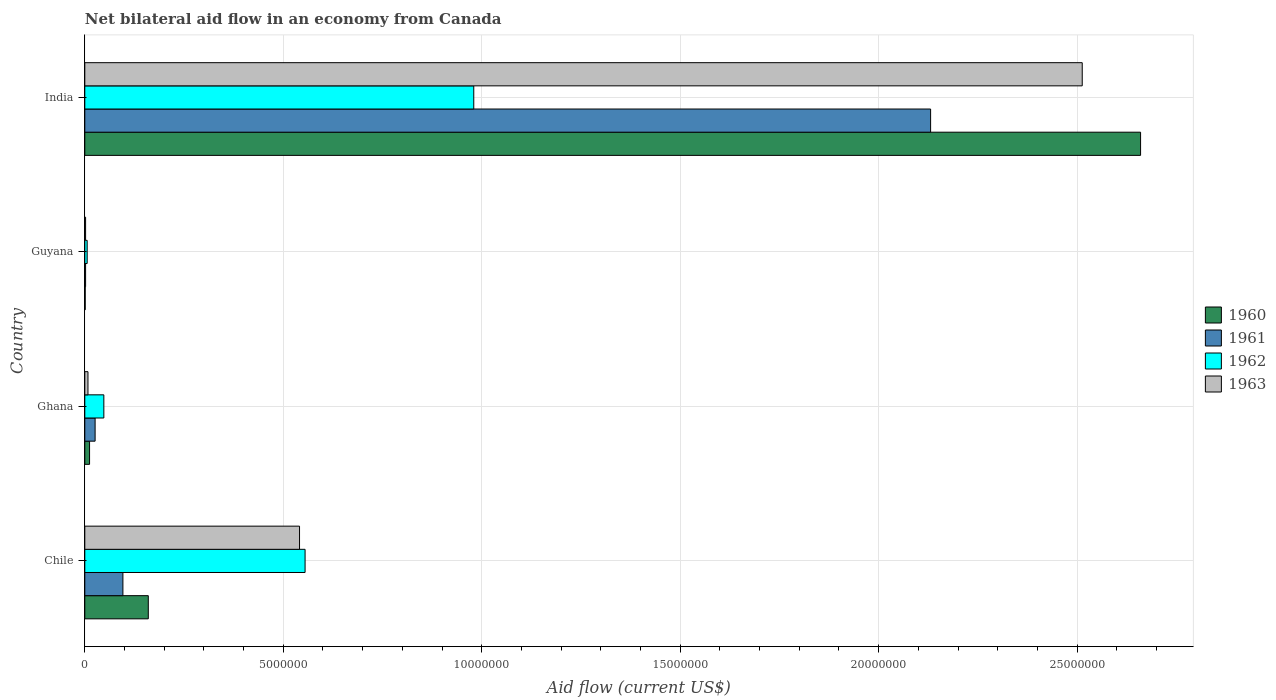How many groups of bars are there?
Provide a succinct answer. 4. Are the number of bars per tick equal to the number of legend labels?
Keep it short and to the point. Yes. Are the number of bars on each tick of the Y-axis equal?
Your answer should be compact. Yes. What is the net bilateral aid flow in 1962 in Ghana?
Your answer should be very brief. 4.80e+05. Across all countries, what is the maximum net bilateral aid flow in 1960?
Your response must be concise. 2.66e+07. In which country was the net bilateral aid flow in 1962 minimum?
Offer a terse response. Guyana. What is the total net bilateral aid flow in 1963 in the graph?
Provide a succinct answer. 3.06e+07. What is the difference between the net bilateral aid flow in 1963 in Guyana and that in India?
Provide a short and direct response. -2.51e+07. What is the difference between the net bilateral aid flow in 1962 in India and the net bilateral aid flow in 1960 in Ghana?
Offer a very short reply. 9.68e+06. What is the average net bilateral aid flow in 1963 per country?
Your answer should be compact. 7.66e+06. In how many countries, is the net bilateral aid flow in 1960 greater than 1000000 US$?
Keep it short and to the point. 2. What is the ratio of the net bilateral aid flow in 1961 in Chile to that in Ghana?
Ensure brevity in your answer.  3.69. Is the net bilateral aid flow in 1960 in Chile less than that in India?
Provide a short and direct response. Yes. What is the difference between the highest and the second highest net bilateral aid flow in 1963?
Your response must be concise. 1.97e+07. What is the difference between the highest and the lowest net bilateral aid flow in 1963?
Provide a succinct answer. 2.51e+07. Is the sum of the net bilateral aid flow in 1960 in Chile and India greater than the maximum net bilateral aid flow in 1961 across all countries?
Give a very brief answer. Yes. Is it the case that in every country, the sum of the net bilateral aid flow in 1963 and net bilateral aid flow in 1961 is greater than the sum of net bilateral aid flow in 1962 and net bilateral aid flow in 1960?
Provide a succinct answer. No. Are all the bars in the graph horizontal?
Ensure brevity in your answer.  Yes. How many countries are there in the graph?
Give a very brief answer. 4. Are the values on the major ticks of X-axis written in scientific E-notation?
Give a very brief answer. No. Does the graph contain grids?
Your answer should be very brief. Yes. How many legend labels are there?
Make the answer very short. 4. What is the title of the graph?
Keep it short and to the point. Net bilateral aid flow in an economy from Canada. What is the label or title of the Y-axis?
Provide a short and direct response. Country. What is the Aid flow (current US$) of 1960 in Chile?
Ensure brevity in your answer.  1.60e+06. What is the Aid flow (current US$) in 1961 in Chile?
Ensure brevity in your answer.  9.60e+05. What is the Aid flow (current US$) in 1962 in Chile?
Give a very brief answer. 5.55e+06. What is the Aid flow (current US$) of 1963 in Chile?
Your answer should be very brief. 5.41e+06. What is the Aid flow (current US$) of 1960 in Ghana?
Ensure brevity in your answer.  1.20e+05. What is the Aid flow (current US$) in 1961 in Ghana?
Keep it short and to the point. 2.60e+05. What is the Aid flow (current US$) of 1962 in Ghana?
Provide a succinct answer. 4.80e+05. What is the Aid flow (current US$) of 1963 in Ghana?
Your answer should be compact. 8.00e+04. What is the Aid flow (current US$) of 1960 in Guyana?
Offer a very short reply. 10000. What is the Aid flow (current US$) of 1962 in Guyana?
Offer a very short reply. 6.00e+04. What is the Aid flow (current US$) in 1960 in India?
Your answer should be compact. 2.66e+07. What is the Aid flow (current US$) of 1961 in India?
Make the answer very short. 2.13e+07. What is the Aid flow (current US$) in 1962 in India?
Offer a terse response. 9.80e+06. What is the Aid flow (current US$) of 1963 in India?
Your answer should be compact. 2.51e+07. Across all countries, what is the maximum Aid flow (current US$) of 1960?
Keep it short and to the point. 2.66e+07. Across all countries, what is the maximum Aid flow (current US$) in 1961?
Provide a succinct answer. 2.13e+07. Across all countries, what is the maximum Aid flow (current US$) in 1962?
Make the answer very short. 9.80e+06. Across all countries, what is the maximum Aid flow (current US$) in 1963?
Provide a short and direct response. 2.51e+07. Across all countries, what is the minimum Aid flow (current US$) in 1960?
Provide a short and direct response. 10000. Across all countries, what is the minimum Aid flow (current US$) in 1961?
Provide a short and direct response. 2.00e+04. What is the total Aid flow (current US$) of 1960 in the graph?
Ensure brevity in your answer.  2.83e+07. What is the total Aid flow (current US$) in 1961 in the graph?
Give a very brief answer. 2.26e+07. What is the total Aid flow (current US$) in 1962 in the graph?
Give a very brief answer. 1.59e+07. What is the total Aid flow (current US$) of 1963 in the graph?
Provide a succinct answer. 3.06e+07. What is the difference between the Aid flow (current US$) of 1960 in Chile and that in Ghana?
Your answer should be very brief. 1.48e+06. What is the difference between the Aid flow (current US$) of 1961 in Chile and that in Ghana?
Provide a succinct answer. 7.00e+05. What is the difference between the Aid flow (current US$) in 1962 in Chile and that in Ghana?
Make the answer very short. 5.07e+06. What is the difference between the Aid flow (current US$) of 1963 in Chile and that in Ghana?
Provide a succinct answer. 5.33e+06. What is the difference between the Aid flow (current US$) in 1960 in Chile and that in Guyana?
Provide a short and direct response. 1.59e+06. What is the difference between the Aid flow (current US$) in 1961 in Chile and that in Guyana?
Provide a short and direct response. 9.40e+05. What is the difference between the Aid flow (current US$) in 1962 in Chile and that in Guyana?
Your answer should be compact. 5.49e+06. What is the difference between the Aid flow (current US$) of 1963 in Chile and that in Guyana?
Provide a succinct answer. 5.39e+06. What is the difference between the Aid flow (current US$) of 1960 in Chile and that in India?
Provide a short and direct response. -2.50e+07. What is the difference between the Aid flow (current US$) in 1961 in Chile and that in India?
Provide a succinct answer. -2.04e+07. What is the difference between the Aid flow (current US$) in 1962 in Chile and that in India?
Provide a succinct answer. -4.25e+06. What is the difference between the Aid flow (current US$) of 1963 in Chile and that in India?
Your answer should be compact. -1.97e+07. What is the difference between the Aid flow (current US$) in 1961 in Ghana and that in Guyana?
Your answer should be very brief. 2.40e+05. What is the difference between the Aid flow (current US$) of 1960 in Ghana and that in India?
Offer a terse response. -2.65e+07. What is the difference between the Aid flow (current US$) of 1961 in Ghana and that in India?
Your response must be concise. -2.10e+07. What is the difference between the Aid flow (current US$) in 1962 in Ghana and that in India?
Make the answer very short. -9.32e+06. What is the difference between the Aid flow (current US$) of 1963 in Ghana and that in India?
Make the answer very short. -2.50e+07. What is the difference between the Aid flow (current US$) in 1960 in Guyana and that in India?
Make the answer very short. -2.66e+07. What is the difference between the Aid flow (current US$) of 1961 in Guyana and that in India?
Keep it short and to the point. -2.13e+07. What is the difference between the Aid flow (current US$) in 1962 in Guyana and that in India?
Give a very brief answer. -9.74e+06. What is the difference between the Aid flow (current US$) of 1963 in Guyana and that in India?
Your answer should be very brief. -2.51e+07. What is the difference between the Aid flow (current US$) of 1960 in Chile and the Aid flow (current US$) of 1961 in Ghana?
Your response must be concise. 1.34e+06. What is the difference between the Aid flow (current US$) of 1960 in Chile and the Aid flow (current US$) of 1962 in Ghana?
Make the answer very short. 1.12e+06. What is the difference between the Aid flow (current US$) of 1960 in Chile and the Aid flow (current US$) of 1963 in Ghana?
Provide a succinct answer. 1.52e+06. What is the difference between the Aid flow (current US$) of 1961 in Chile and the Aid flow (current US$) of 1963 in Ghana?
Make the answer very short. 8.80e+05. What is the difference between the Aid flow (current US$) of 1962 in Chile and the Aid flow (current US$) of 1963 in Ghana?
Keep it short and to the point. 5.47e+06. What is the difference between the Aid flow (current US$) in 1960 in Chile and the Aid flow (current US$) in 1961 in Guyana?
Make the answer very short. 1.58e+06. What is the difference between the Aid flow (current US$) of 1960 in Chile and the Aid flow (current US$) of 1962 in Guyana?
Your answer should be compact. 1.54e+06. What is the difference between the Aid flow (current US$) in 1960 in Chile and the Aid flow (current US$) in 1963 in Guyana?
Provide a succinct answer. 1.58e+06. What is the difference between the Aid flow (current US$) of 1961 in Chile and the Aid flow (current US$) of 1962 in Guyana?
Your response must be concise. 9.00e+05. What is the difference between the Aid flow (current US$) of 1961 in Chile and the Aid flow (current US$) of 1963 in Guyana?
Make the answer very short. 9.40e+05. What is the difference between the Aid flow (current US$) of 1962 in Chile and the Aid flow (current US$) of 1963 in Guyana?
Ensure brevity in your answer.  5.53e+06. What is the difference between the Aid flow (current US$) of 1960 in Chile and the Aid flow (current US$) of 1961 in India?
Give a very brief answer. -1.97e+07. What is the difference between the Aid flow (current US$) of 1960 in Chile and the Aid flow (current US$) of 1962 in India?
Give a very brief answer. -8.20e+06. What is the difference between the Aid flow (current US$) in 1960 in Chile and the Aid flow (current US$) in 1963 in India?
Ensure brevity in your answer.  -2.35e+07. What is the difference between the Aid flow (current US$) in 1961 in Chile and the Aid flow (current US$) in 1962 in India?
Provide a short and direct response. -8.84e+06. What is the difference between the Aid flow (current US$) of 1961 in Chile and the Aid flow (current US$) of 1963 in India?
Ensure brevity in your answer.  -2.42e+07. What is the difference between the Aid flow (current US$) in 1962 in Chile and the Aid flow (current US$) in 1963 in India?
Keep it short and to the point. -1.96e+07. What is the difference between the Aid flow (current US$) in 1960 in Ghana and the Aid flow (current US$) in 1961 in Guyana?
Your response must be concise. 1.00e+05. What is the difference between the Aid flow (current US$) of 1960 in Ghana and the Aid flow (current US$) of 1963 in Guyana?
Offer a very short reply. 1.00e+05. What is the difference between the Aid flow (current US$) of 1961 in Ghana and the Aid flow (current US$) of 1962 in Guyana?
Offer a terse response. 2.00e+05. What is the difference between the Aid flow (current US$) in 1961 in Ghana and the Aid flow (current US$) in 1963 in Guyana?
Your answer should be compact. 2.40e+05. What is the difference between the Aid flow (current US$) in 1962 in Ghana and the Aid flow (current US$) in 1963 in Guyana?
Keep it short and to the point. 4.60e+05. What is the difference between the Aid flow (current US$) in 1960 in Ghana and the Aid flow (current US$) in 1961 in India?
Your answer should be very brief. -2.12e+07. What is the difference between the Aid flow (current US$) of 1960 in Ghana and the Aid flow (current US$) of 1962 in India?
Give a very brief answer. -9.68e+06. What is the difference between the Aid flow (current US$) in 1960 in Ghana and the Aid flow (current US$) in 1963 in India?
Provide a short and direct response. -2.50e+07. What is the difference between the Aid flow (current US$) in 1961 in Ghana and the Aid flow (current US$) in 1962 in India?
Your answer should be compact. -9.54e+06. What is the difference between the Aid flow (current US$) in 1961 in Ghana and the Aid flow (current US$) in 1963 in India?
Offer a very short reply. -2.49e+07. What is the difference between the Aid flow (current US$) in 1962 in Ghana and the Aid flow (current US$) in 1963 in India?
Keep it short and to the point. -2.46e+07. What is the difference between the Aid flow (current US$) in 1960 in Guyana and the Aid flow (current US$) in 1961 in India?
Offer a terse response. -2.13e+07. What is the difference between the Aid flow (current US$) of 1960 in Guyana and the Aid flow (current US$) of 1962 in India?
Ensure brevity in your answer.  -9.79e+06. What is the difference between the Aid flow (current US$) in 1960 in Guyana and the Aid flow (current US$) in 1963 in India?
Offer a terse response. -2.51e+07. What is the difference between the Aid flow (current US$) in 1961 in Guyana and the Aid flow (current US$) in 1962 in India?
Keep it short and to the point. -9.78e+06. What is the difference between the Aid flow (current US$) in 1961 in Guyana and the Aid flow (current US$) in 1963 in India?
Offer a terse response. -2.51e+07. What is the difference between the Aid flow (current US$) of 1962 in Guyana and the Aid flow (current US$) of 1963 in India?
Your answer should be very brief. -2.51e+07. What is the average Aid flow (current US$) in 1960 per country?
Offer a very short reply. 7.08e+06. What is the average Aid flow (current US$) of 1961 per country?
Provide a short and direct response. 5.64e+06. What is the average Aid flow (current US$) in 1962 per country?
Give a very brief answer. 3.97e+06. What is the average Aid flow (current US$) in 1963 per country?
Provide a short and direct response. 7.66e+06. What is the difference between the Aid flow (current US$) of 1960 and Aid flow (current US$) of 1961 in Chile?
Provide a short and direct response. 6.40e+05. What is the difference between the Aid flow (current US$) of 1960 and Aid flow (current US$) of 1962 in Chile?
Keep it short and to the point. -3.95e+06. What is the difference between the Aid flow (current US$) of 1960 and Aid flow (current US$) of 1963 in Chile?
Provide a succinct answer. -3.81e+06. What is the difference between the Aid flow (current US$) in 1961 and Aid flow (current US$) in 1962 in Chile?
Your response must be concise. -4.59e+06. What is the difference between the Aid flow (current US$) of 1961 and Aid flow (current US$) of 1963 in Chile?
Make the answer very short. -4.45e+06. What is the difference between the Aid flow (current US$) in 1960 and Aid flow (current US$) in 1961 in Ghana?
Keep it short and to the point. -1.40e+05. What is the difference between the Aid flow (current US$) in 1960 and Aid flow (current US$) in 1962 in Ghana?
Your answer should be very brief. -3.60e+05. What is the difference between the Aid flow (current US$) of 1960 and Aid flow (current US$) of 1963 in Ghana?
Your response must be concise. 4.00e+04. What is the difference between the Aid flow (current US$) in 1961 and Aid flow (current US$) in 1963 in Ghana?
Ensure brevity in your answer.  1.80e+05. What is the difference between the Aid flow (current US$) in 1962 and Aid flow (current US$) in 1963 in Ghana?
Your answer should be compact. 4.00e+05. What is the difference between the Aid flow (current US$) of 1960 and Aid flow (current US$) of 1961 in Guyana?
Offer a very short reply. -10000. What is the difference between the Aid flow (current US$) in 1960 and Aid flow (current US$) in 1963 in Guyana?
Your answer should be compact. -10000. What is the difference between the Aid flow (current US$) in 1960 and Aid flow (current US$) in 1961 in India?
Offer a terse response. 5.29e+06. What is the difference between the Aid flow (current US$) in 1960 and Aid flow (current US$) in 1962 in India?
Your answer should be very brief. 1.68e+07. What is the difference between the Aid flow (current US$) in 1960 and Aid flow (current US$) in 1963 in India?
Ensure brevity in your answer.  1.47e+06. What is the difference between the Aid flow (current US$) in 1961 and Aid flow (current US$) in 1962 in India?
Your answer should be very brief. 1.15e+07. What is the difference between the Aid flow (current US$) of 1961 and Aid flow (current US$) of 1963 in India?
Your answer should be very brief. -3.82e+06. What is the difference between the Aid flow (current US$) in 1962 and Aid flow (current US$) in 1963 in India?
Provide a short and direct response. -1.53e+07. What is the ratio of the Aid flow (current US$) of 1960 in Chile to that in Ghana?
Offer a very short reply. 13.33. What is the ratio of the Aid flow (current US$) in 1961 in Chile to that in Ghana?
Provide a short and direct response. 3.69. What is the ratio of the Aid flow (current US$) of 1962 in Chile to that in Ghana?
Your response must be concise. 11.56. What is the ratio of the Aid flow (current US$) in 1963 in Chile to that in Ghana?
Offer a very short reply. 67.62. What is the ratio of the Aid flow (current US$) of 1960 in Chile to that in Guyana?
Make the answer very short. 160. What is the ratio of the Aid flow (current US$) in 1962 in Chile to that in Guyana?
Make the answer very short. 92.5. What is the ratio of the Aid flow (current US$) in 1963 in Chile to that in Guyana?
Your answer should be very brief. 270.5. What is the ratio of the Aid flow (current US$) in 1960 in Chile to that in India?
Your response must be concise. 0.06. What is the ratio of the Aid flow (current US$) of 1961 in Chile to that in India?
Provide a short and direct response. 0.04. What is the ratio of the Aid flow (current US$) of 1962 in Chile to that in India?
Offer a terse response. 0.57. What is the ratio of the Aid flow (current US$) in 1963 in Chile to that in India?
Offer a very short reply. 0.22. What is the ratio of the Aid flow (current US$) of 1963 in Ghana to that in Guyana?
Offer a very short reply. 4. What is the ratio of the Aid flow (current US$) in 1960 in Ghana to that in India?
Provide a succinct answer. 0. What is the ratio of the Aid flow (current US$) in 1961 in Ghana to that in India?
Provide a short and direct response. 0.01. What is the ratio of the Aid flow (current US$) of 1962 in Ghana to that in India?
Offer a very short reply. 0.05. What is the ratio of the Aid flow (current US$) in 1963 in Ghana to that in India?
Provide a succinct answer. 0. What is the ratio of the Aid flow (current US$) of 1960 in Guyana to that in India?
Your answer should be compact. 0. What is the ratio of the Aid flow (current US$) of 1961 in Guyana to that in India?
Keep it short and to the point. 0. What is the ratio of the Aid flow (current US$) of 1962 in Guyana to that in India?
Your response must be concise. 0.01. What is the ratio of the Aid flow (current US$) of 1963 in Guyana to that in India?
Your answer should be compact. 0. What is the difference between the highest and the second highest Aid flow (current US$) in 1960?
Make the answer very short. 2.50e+07. What is the difference between the highest and the second highest Aid flow (current US$) in 1961?
Offer a terse response. 2.04e+07. What is the difference between the highest and the second highest Aid flow (current US$) of 1962?
Offer a terse response. 4.25e+06. What is the difference between the highest and the second highest Aid flow (current US$) in 1963?
Provide a short and direct response. 1.97e+07. What is the difference between the highest and the lowest Aid flow (current US$) in 1960?
Offer a very short reply. 2.66e+07. What is the difference between the highest and the lowest Aid flow (current US$) in 1961?
Provide a succinct answer. 2.13e+07. What is the difference between the highest and the lowest Aid flow (current US$) of 1962?
Keep it short and to the point. 9.74e+06. What is the difference between the highest and the lowest Aid flow (current US$) of 1963?
Give a very brief answer. 2.51e+07. 